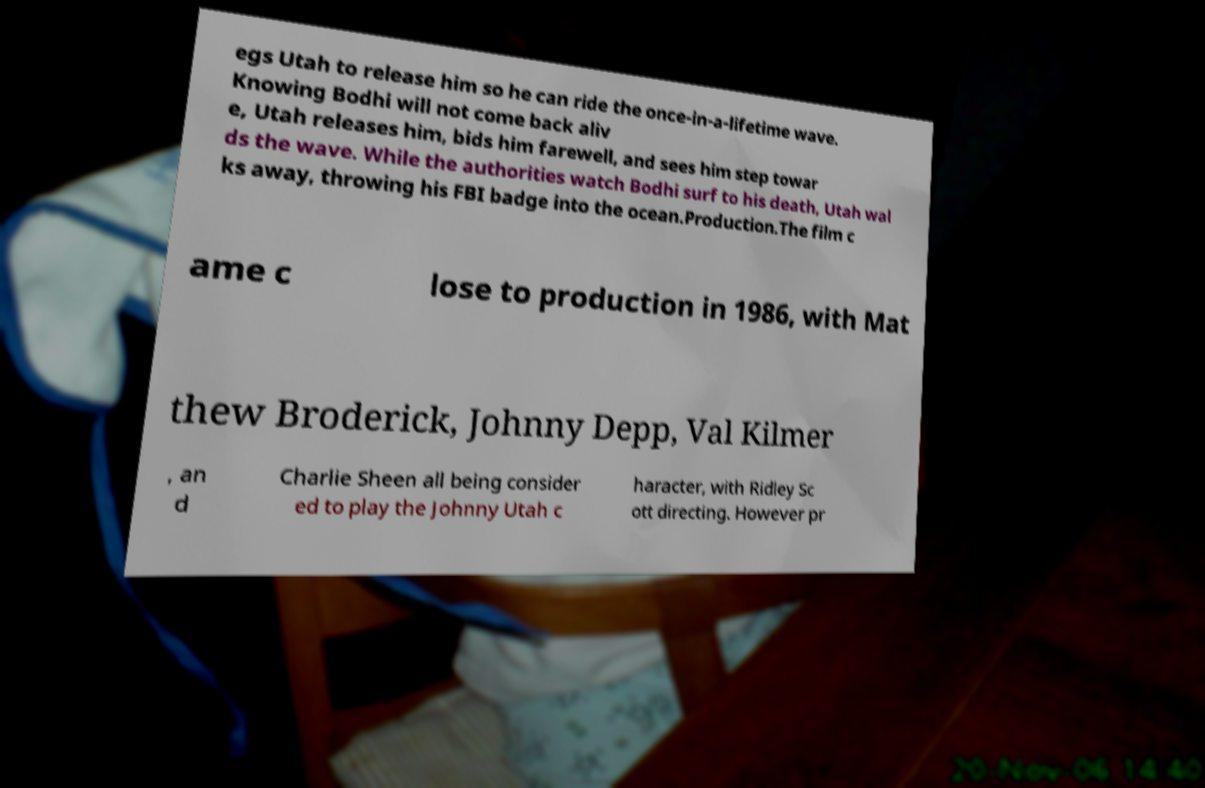For documentation purposes, I need the text within this image transcribed. Could you provide that? egs Utah to release him so he can ride the once-in-a-lifetime wave. Knowing Bodhi will not come back aliv e, Utah releases him, bids him farewell, and sees him step towar ds the wave. While the authorities watch Bodhi surf to his death, Utah wal ks away, throwing his FBI badge into the ocean.Production.The film c ame c lose to production in 1986, with Mat thew Broderick, Johnny Depp, Val Kilmer , an d Charlie Sheen all being consider ed to play the Johnny Utah c haracter, with Ridley Sc ott directing. However pr 